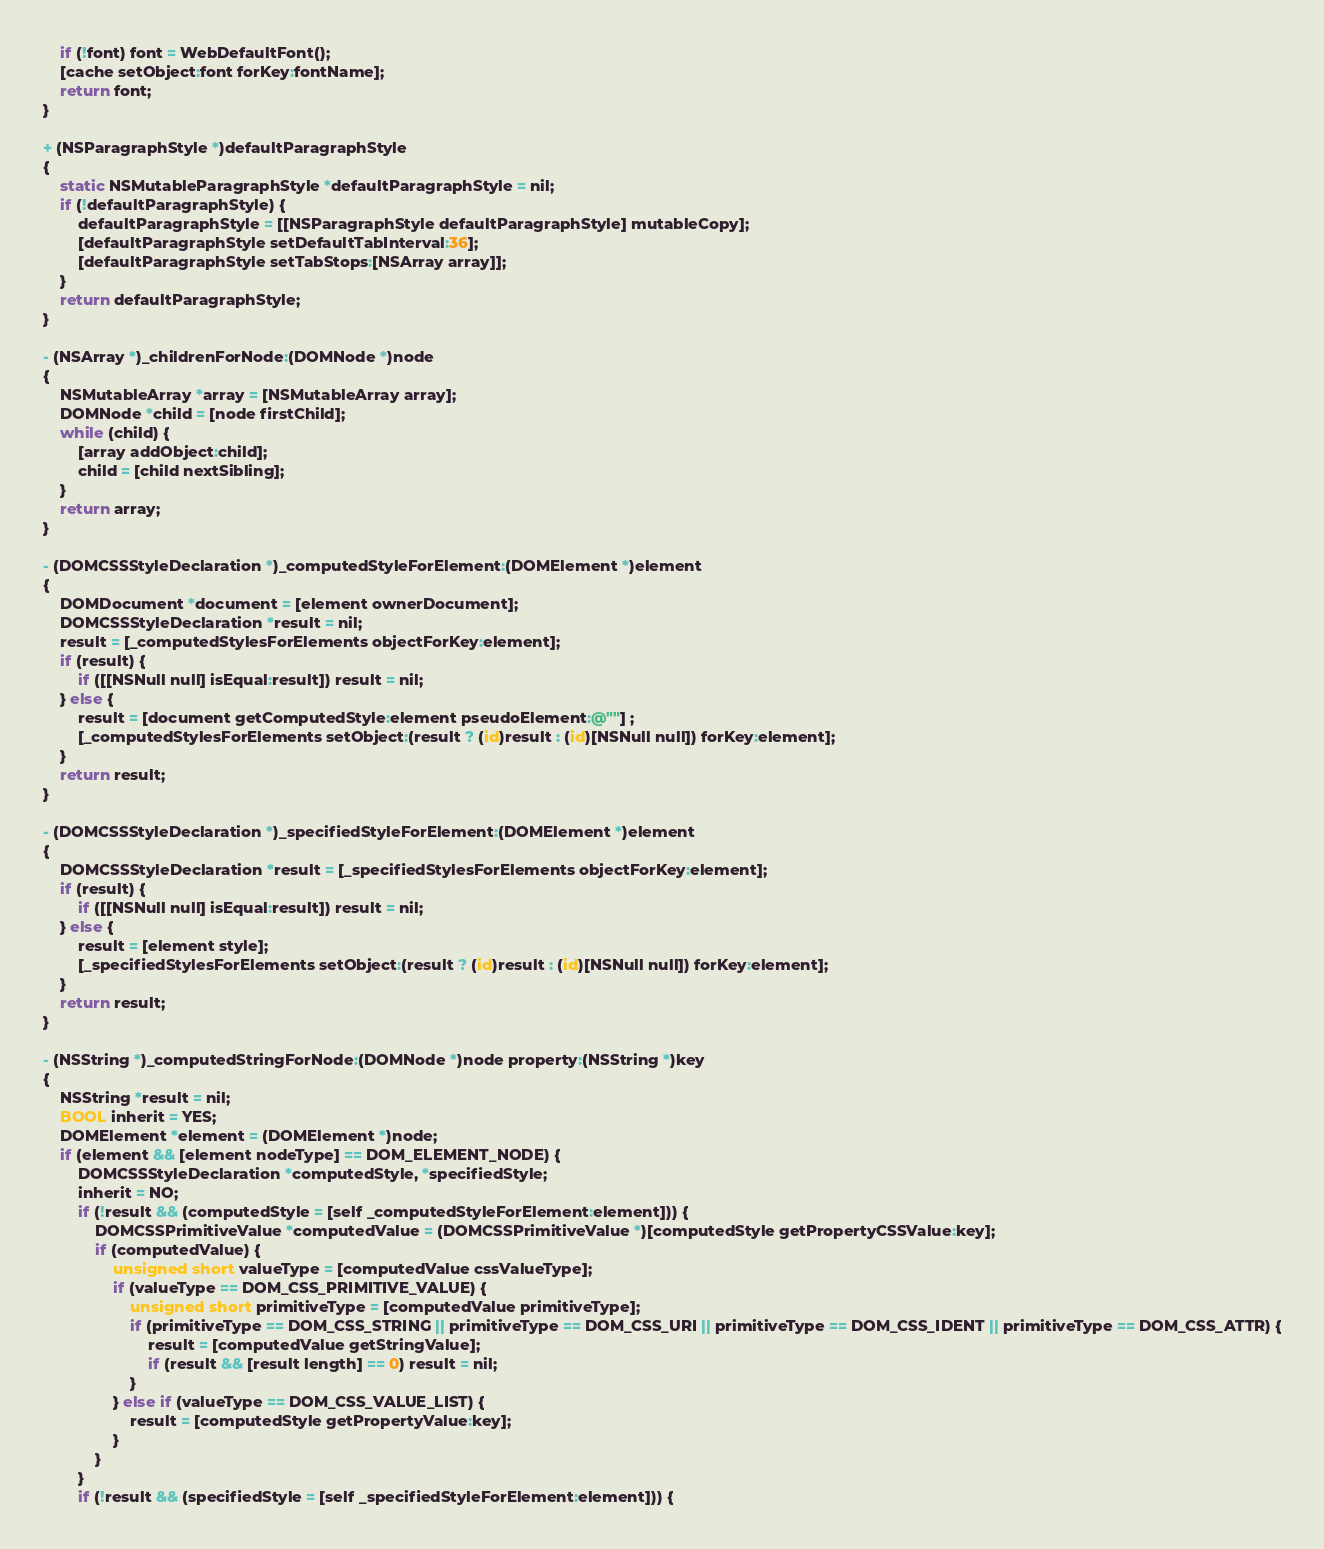Convert code to text. <code><loc_0><loc_0><loc_500><loc_500><_ObjectiveC_>    if (!font) font = WebDefaultFont();
    [cache setObject:font forKey:fontName];
    return font;
}

+ (NSParagraphStyle *)defaultParagraphStyle
{
    static NSMutableParagraphStyle *defaultParagraphStyle = nil;
    if (!defaultParagraphStyle) {
        defaultParagraphStyle = [[NSParagraphStyle defaultParagraphStyle] mutableCopy];
        [defaultParagraphStyle setDefaultTabInterval:36];
        [defaultParagraphStyle setTabStops:[NSArray array]];
    }
    return defaultParagraphStyle;
}

- (NSArray *)_childrenForNode:(DOMNode *)node
{
    NSMutableArray *array = [NSMutableArray array];
    DOMNode *child = [node firstChild];
    while (child) {
        [array addObject:child];
        child = [child nextSibling];
    }
    return array;
}

- (DOMCSSStyleDeclaration *)_computedStyleForElement:(DOMElement *)element
{
    DOMDocument *document = [element ownerDocument];
    DOMCSSStyleDeclaration *result = nil;
    result = [_computedStylesForElements objectForKey:element];
    if (result) {
        if ([[NSNull null] isEqual:result]) result = nil;
    } else {
        result = [document getComputedStyle:element pseudoElement:@""] ;
        [_computedStylesForElements setObject:(result ? (id)result : (id)[NSNull null]) forKey:element];
    }
    return result;
}

- (DOMCSSStyleDeclaration *)_specifiedStyleForElement:(DOMElement *)element
{
    DOMCSSStyleDeclaration *result = [_specifiedStylesForElements objectForKey:element];
    if (result) {
        if ([[NSNull null] isEqual:result]) result = nil;
    } else {
        result = [element style];
        [_specifiedStylesForElements setObject:(result ? (id)result : (id)[NSNull null]) forKey:element];
    }
    return result;
}

- (NSString *)_computedStringForNode:(DOMNode *)node property:(NSString *)key
{
    NSString *result = nil;
    BOOL inherit = YES;
    DOMElement *element = (DOMElement *)node;    
    if (element && [element nodeType] == DOM_ELEMENT_NODE) {
        DOMCSSStyleDeclaration *computedStyle, *specifiedStyle;
        inherit = NO;
        if (!result && (computedStyle = [self _computedStyleForElement:element])) {
            DOMCSSPrimitiveValue *computedValue = (DOMCSSPrimitiveValue *)[computedStyle getPropertyCSSValue:key];
            if (computedValue) {
                unsigned short valueType = [computedValue cssValueType];
                if (valueType == DOM_CSS_PRIMITIVE_VALUE) {
                    unsigned short primitiveType = [computedValue primitiveType];
                    if (primitiveType == DOM_CSS_STRING || primitiveType == DOM_CSS_URI || primitiveType == DOM_CSS_IDENT || primitiveType == DOM_CSS_ATTR) {
                        result = [computedValue getStringValue];
                        if (result && [result length] == 0) result = nil;
                    }
                } else if (valueType == DOM_CSS_VALUE_LIST) {
                    result = [computedStyle getPropertyValue:key];
                }
            }
        }
        if (!result && (specifiedStyle = [self _specifiedStyleForElement:element])) {</code> 